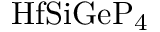Convert formula to latex. <formula><loc_0><loc_0><loc_500><loc_500>H f S i G e P _ { 4 }</formula> 